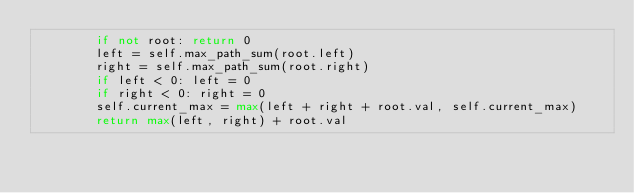Convert code to text. <code><loc_0><loc_0><loc_500><loc_500><_Python_>        if not root: return 0
        left = self.max_path_sum(root.left)
        right = self.max_path_sum(root.right)
        if left < 0: left = 0
        if right < 0: right = 0
        self.current_max = max(left + right + root.val, self.current_max)
        return max(left, right) + root.val
</code> 